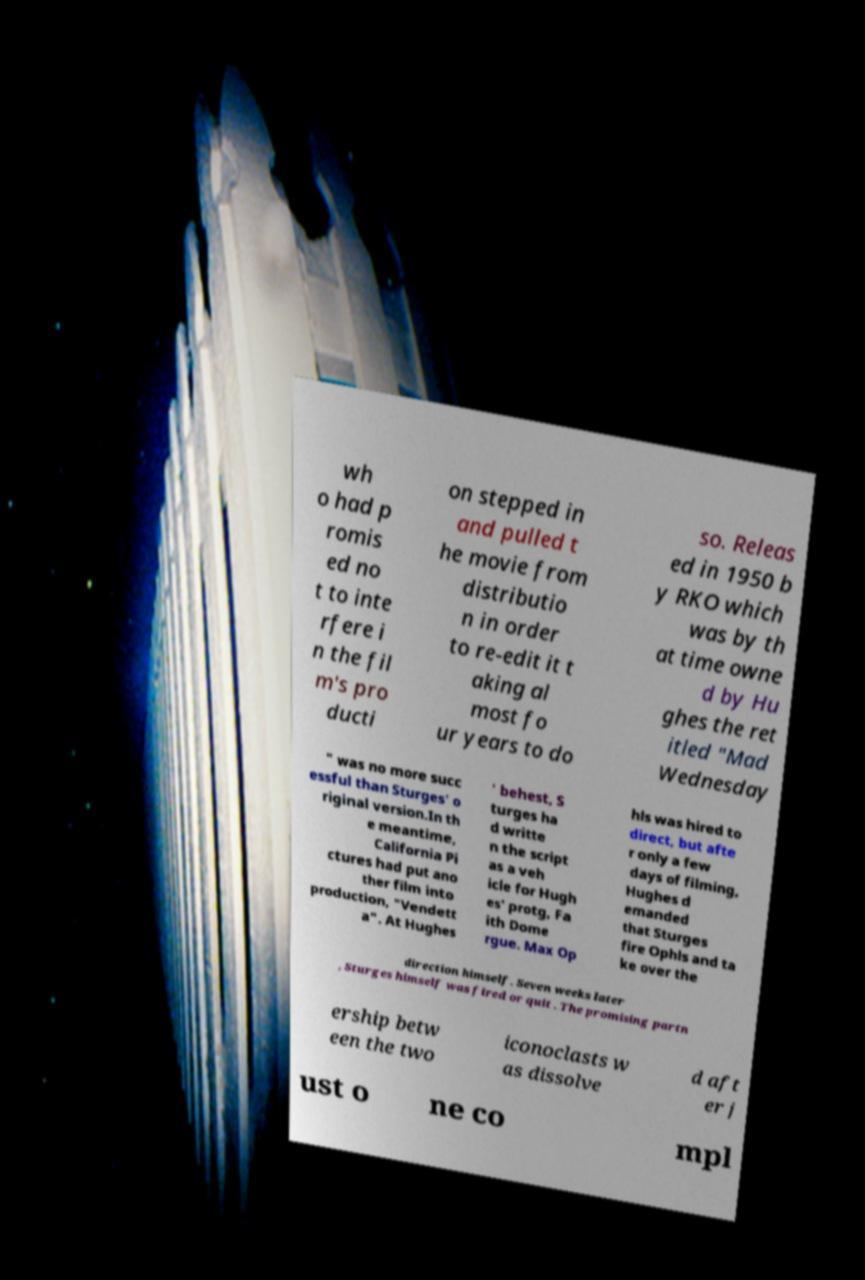Can you accurately transcribe the text from the provided image for me? wh o had p romis ed no t to inte rfere i n the fil m's pro ducti on stepped in and pulled t he movie from distributio n in order to re-edit it t aking al most fo ur years to do so. Releas ed in 1950 b y RKO which was by th at time owne d by Hu ghes the ret itled "Mad Wednesday " was no more succ essful than Sturges' o riginal version.In th e meantime, California Pi ctures had put ano ther film into production, "Vendett a". At Hughes ' behest, S turges ha d writte n the script as a veh icle for Hugh es' protg, Fa ith Dome rgue. Max Op hls was hired to direct, but afte r only a few days of filming, Hughes d emanded that Sturges fire Ophls and ta ke over the direction himself. Seven weeks later , Sturges himself was fired or quit . The promising partn ership betw een the two iconoclasts w as dissolve d aft er j ust o ne co mpl 